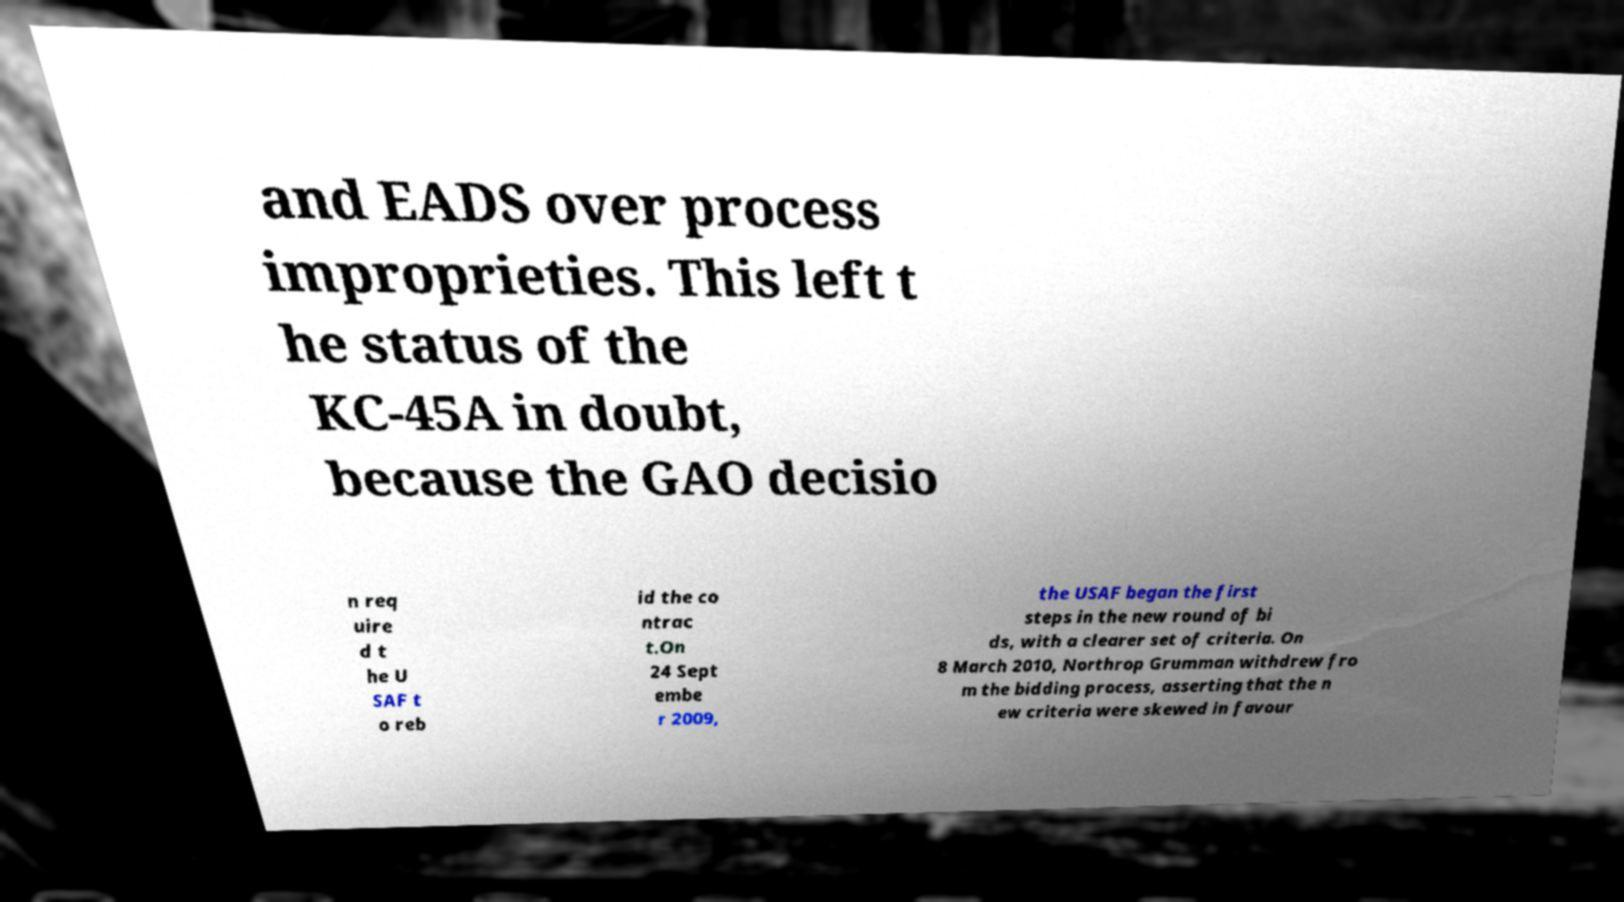There's text embedded in this image that I need extracted. Can you transcribe it verbatim? and EADS over process improprieties. This left t he status of the KC-45A in doubt, because the GAO decisio n req uire d t he U SAF t o reb id the co ntrac t.On 24 Sept embe r 2009, the USAF began the first steps in the new round of bi ds, with a clearer set of criteria. On 8 March 2010, Northrop Grumman withdrew fro m the bidding process, asserting that the n ew criteria were skewed in favour 